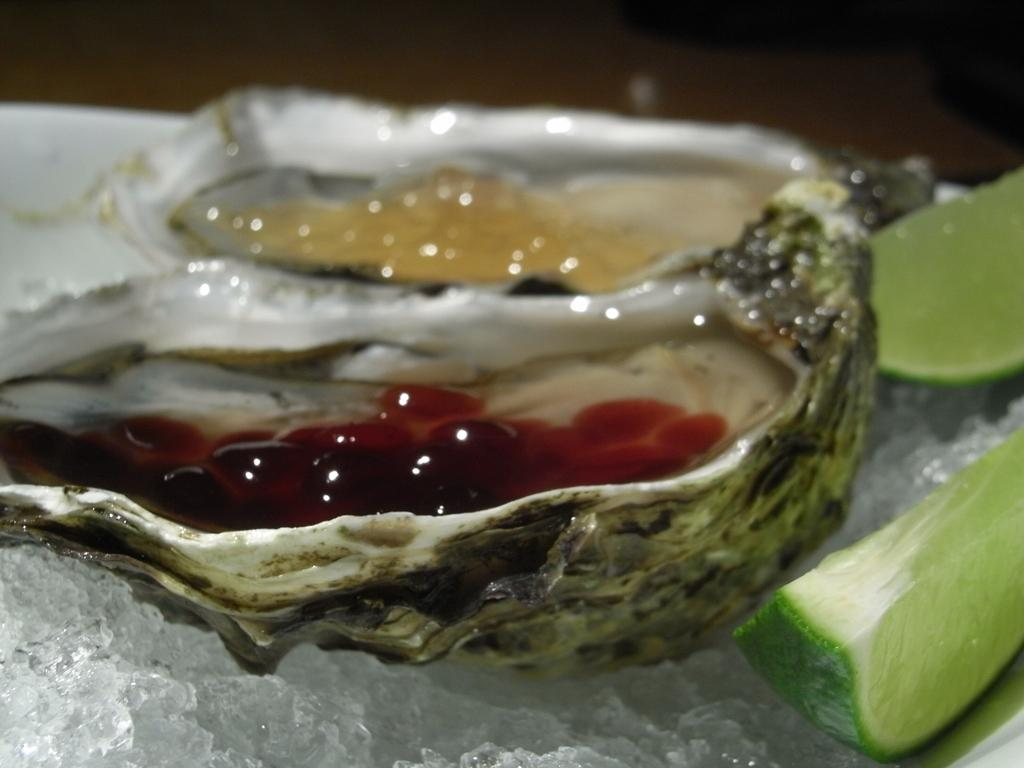What is the main subject in the center of the image? There is a white object in the center of the image. What is inside the white object? The white object contains lemon slices, ice, and some food items. What can be inferred about the purpose of the white object? The white object appears to be a container for chilled food items, such as lemon slices and other food items. How would you describe the background of the image? The background of the image is dark. What grade does the alley receive in the image? There is no alley present in the image, so it is not possible to assign a grade to it. 